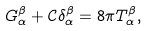<formula> <loc_0><loc_0><loc_500><loc_500>G _ { \alpha } ^ { \beta } + \mathcal { C } \delta _ { \alpha } ^ { \beta } = 8 \pi T _ { \alpha } ^ { \beta } ,</formula> 